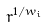<formula> <loc_0><loc_0><loc_500><loc_500>r ^ { 1 / w _ { i } }</formula> 